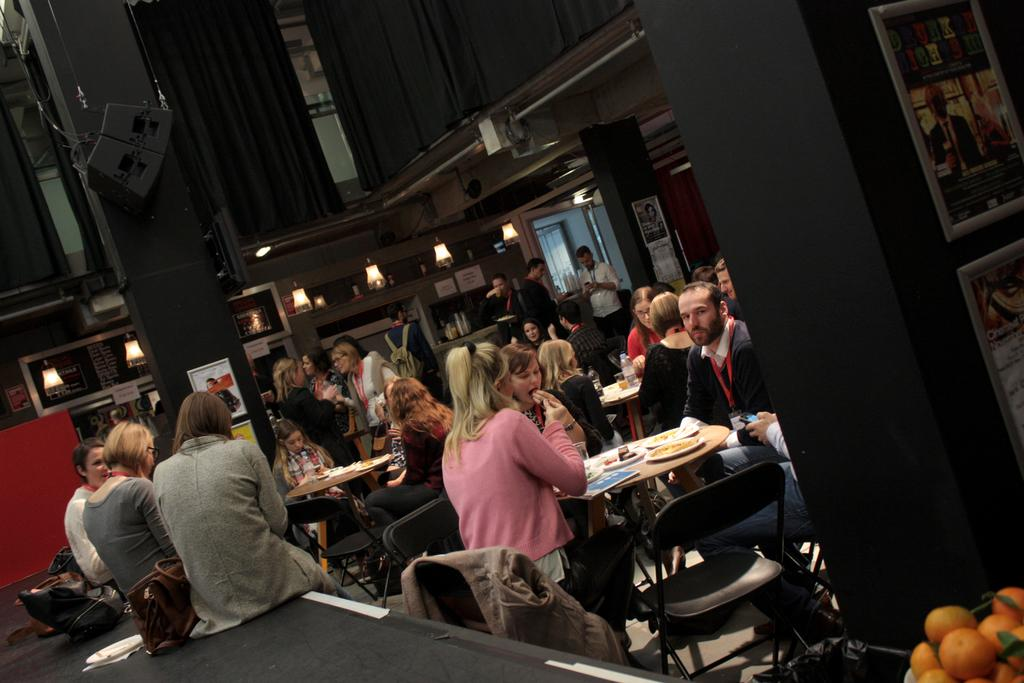Who or what is present in the image? There are people in the image. What furniture can be seen in the image? There are chairs in the image. What is on the table in the image? There are objects on the table. What is the source of light in the image? There is a light visible at the top of the image. Can you describe the dog that is fighting with the people in the image? There is no dog present in the image, nor is there any fighting depicted. 